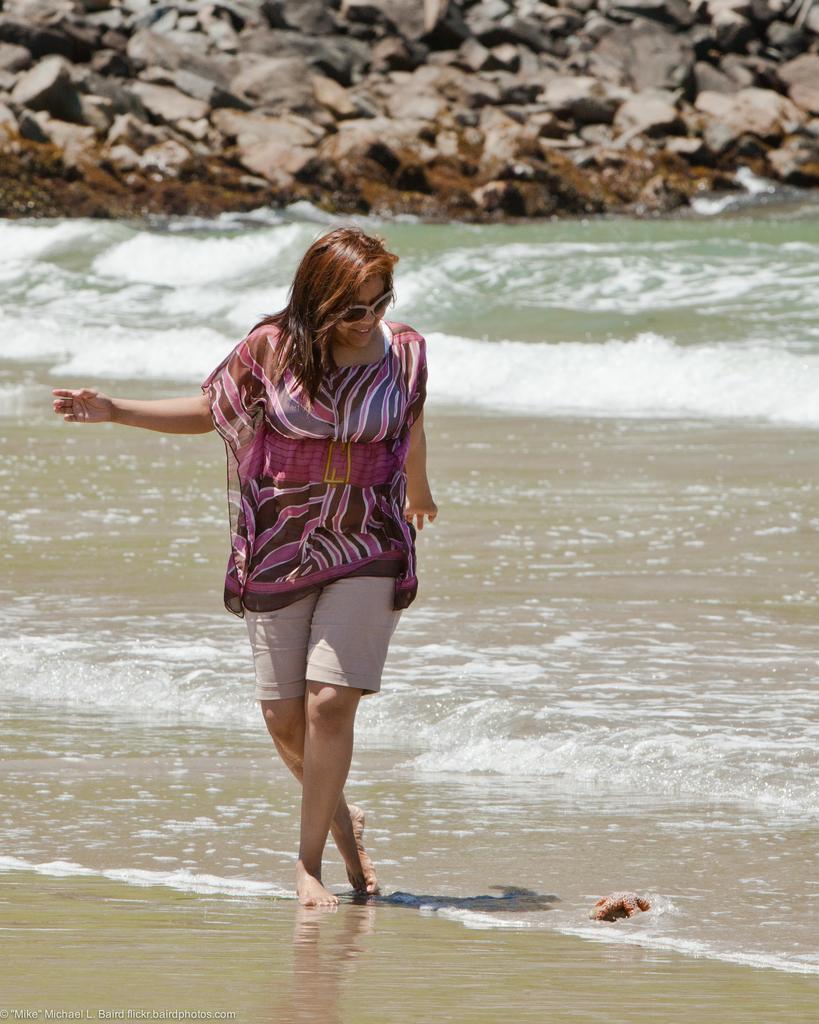Could you give a brief overview of what you see in this image? In the middle of the image a woman is walking and smiling. Behind her there is water and there are some stones. 